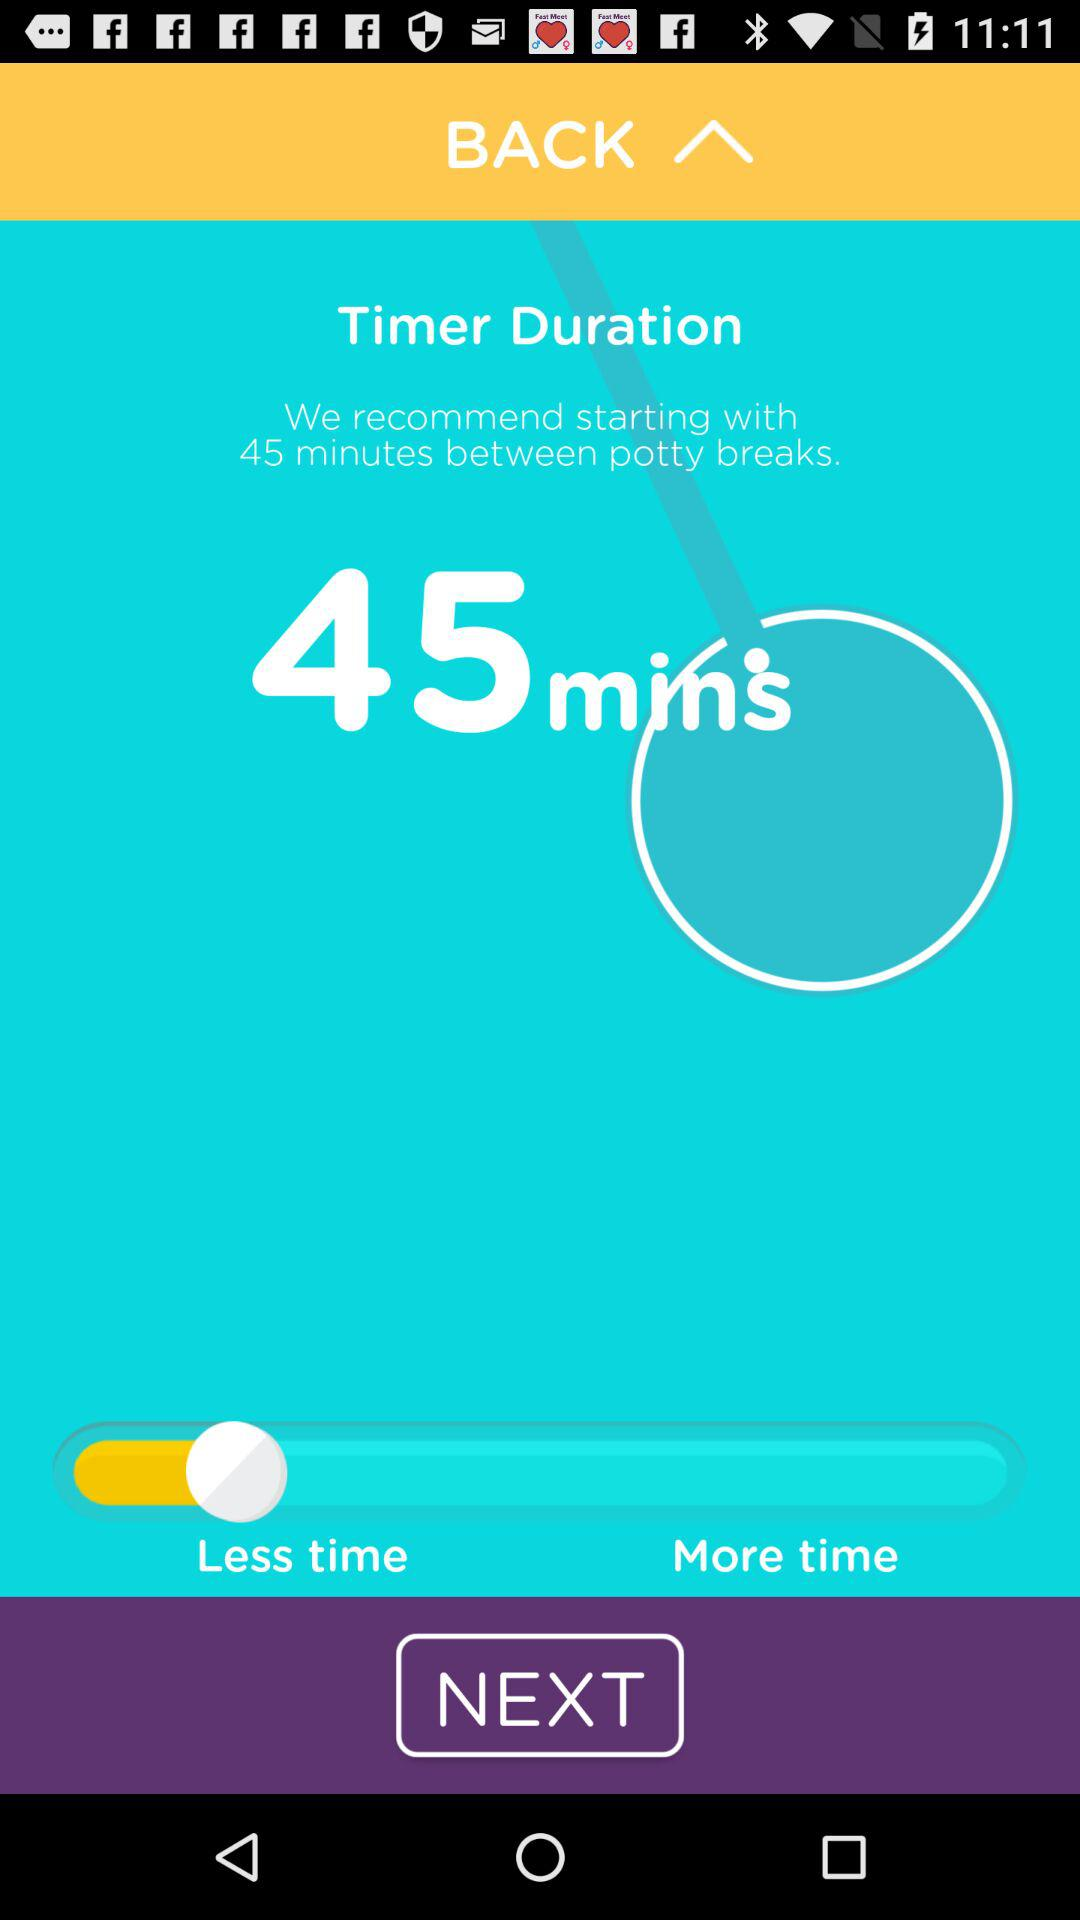Can you explain how to use the features seen on the screen? The screen shows a timer set for 45 minutes which is recommended for scheduling breaks, possibly for potty training children. You can adjust the time duration by moving the slider left for less time or right for more time. Tapping 'Next' will likely take you to further settings or start the timer. 